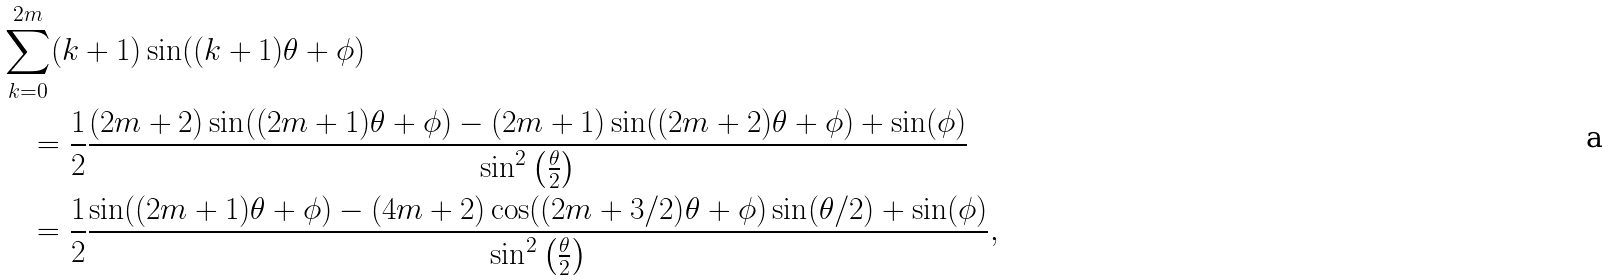Convert formula to latex. <formula><loc_0><loc_0><loc_500><loc_500>& \sum _ { k = 0 } ^ { 2 m } ( k + 1 ) \sin ( ( k + 1 ) \theta + \phi ) \\ & \quad = \frac { 1 } { 2 } \frac { ( 2 m + 2 ) \sin ( ( 2 m + 1 ) \theta + \phi ) - ( 2 m + 1 ) \sin ( ( 2 m + 2 ) \theta + \phi ) + \sin ( \phi ) } { \sin ^ { 2 } \left ( \frac { \theta } { 2 } \right ) } \\ & \quad = \frac { 1 } { 2 } \frac { \sin ( ( 2 m + 1 ) \theta + \phi ) - ( 4 m + 2 ) \cos ( ( 2 m + 3 / 2 ) \theta + \phi ) \sin ( \theta / 2 ) + \sin ( \phi ) } { \sin ^ { 2 } \left ( \frac { \theta } { 2 } \right ) } ,</formula> 